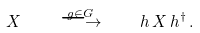Convert formula to latex. <formula><loc_0><loc_0><loc_500><loc_500>X \quad \stackrel { g \in G } { \longrightarrow } \quad h \, X \, h ^ { \dagger } \, .</formula> 